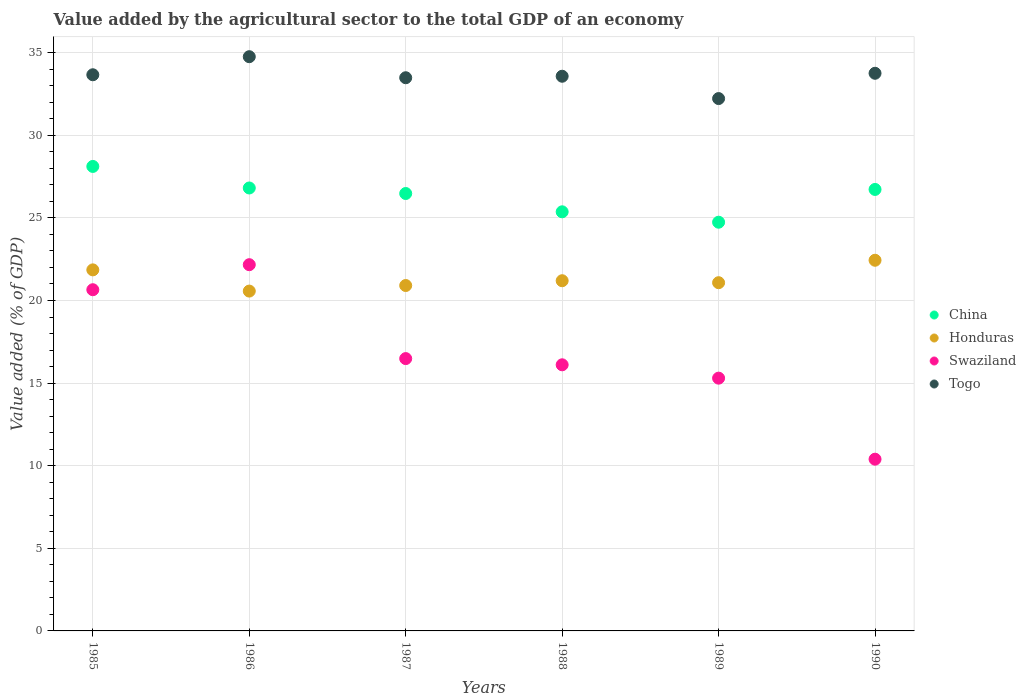How many different coloured dotlines are there?
Ensure brevity in your answer.  4. Is the number of dotlines equal to the number of legend labels?
Your answer should be very brief. Yes. What is the value added by the agricultural sector to the total GDP in Togo in 1989?
Give a very brief answer. 32.22. Across all years, what is the maximum value added by the agricultural sector to the total GDP in Togo?
Make the answer very short. 34.76. Across all years, what is the minimum value added by the agricultural sector to the total GDP in Togo?
Keep it short and to the point. 32.22. In which year was the value added by the agricultural sector to the total GDP in Honduras maximum?
Your response must be concise. 1990. In which year was the value added by the agricultural sector to the total GDP in Swaziland minimum?
Your answer should be compact. 1990. What is the total value added by the agricultural sector to the total GDP in China in the graph?
Provide a short and direct response. 158.23. What is the difference between the value added by the agricultural sector to the total GDP in China in 1987 and that in 1990?
Ensure brevity in your answer.  -0.25. What is the difference between the value added by the agricultural sector to the total GDP in China in 1989 and the value added by the agricultural sector to the total GDP in Togo in 1987?
Provide a short and direct response. -8.75. What is the average value added by the agricultural sector to the total GDP in Honduras per year?
Provide a short and direct response. 21.34. In the year 1986, what is the difference between the value added by the agricultural sector to the total GDP in Swaziland and value added by the agricultural sector to the total GDP in Honduras?
Your answer should be compact. 1.6. What is the ratio of the value added by the agricultural sector to the total GDP in Swaziland in 1985 to that in 1986?
Your answer should be very brief. 0.93. Is the value added by the agricultural sector to the total GDP in Honduras in 1989 less than that in 1990?
Provide a succinct answer. Yes. Is the difference between the value added by the agricultural sector to the total GDP in Swaziland in 1985 and 1986 greater than the difference between the value added by the agricultural sector to the total GDP in Honduras in 1985 and 1986?
Your answer should be very brief. No. What is the difference between the highest and the second highest value added by the agricultural sector to the total GDP in Swaziland?
Your response must be concise. 1.51. What is the difference between the highest and the lowest value added by the agricultural sector to the total GDP in Honduras?
Ensure brevity in your answer.  1.87. Is the sum of the value added by the agricultural sector to the total GDP in China in 1985 and 1986 greater than the maximum value added by the agricultural sector to the total GDP in Honduras across all years?
Offer a terse response. Yes. Does the value added by the agricultural sector to the total GDP in Togo monotonically increase over the years?
Give a very brief answer. No. Is the value added by the agricultural sector to the total GDP in Swaziland strictly greater than the value added by the agricultural sector to the total GDP in Honduras over the years?
Your answer should be very brief. No. Is the value added by the agricultural sector to the total GDP in Swaziland strictly less than the value added by the agricultural sector to the total GDP in Togo over the years?
Ensure brevity in your answer.  Yes. How many years are there in the graph?
Your response must be concise. 6. What is the title of the graph?
Offer a very short reply. Value added by the agricultural sector to the total GDP of an economy. Does "Libya" appear as one of the legend labels in the graph?
Offer a terse response. No. What is the label or title of the Y-axis?
Offer a very short reply. Value added (% of GDP). What is the Value added (% of GDP) in China in 1985?
Keep it short and to the point. 28.12. What is the Value added (% of GDP) in Honduras in 1985?
Offer a terse response. 21.85. What is the Value added (% of GDP) in Swaziland in 1985?
Give a very brief answer. 20.65. What is the Value added (% of GDP) in Togo in 1985?
Provide a succinct answer. 33.66. What is the Value added (% of GDP) in China in 1986?
Your answer should be very brief. 26.81. What is the Value added (% of GDP) of Honduras in 1986?
Ensure brevity in your answer.  20.57. What is the Value added (% of GDP) of Swaziland in 1986?
Give a very brief answer. 22.17. What is the Value added (% of GDP) of Togo in 1986?
Provide a short and direct response. 34.76. What is the Value added (% of GDP) of China in 1987?
Give a very brief answer. 26.48. What is the Value added (% of GDP) in Honduras in 1987?
Provide a short and direct response. 20.91. What is the Value added (% of GDP) of Swaziland in 1987?
Your answer should be compact. 16.48. What is the Value added (% of GDP) in Togo in 1987?
Offer a terse response. 33.48. What is the Value added (% of GDP) in China in 1988?
Ensure brevity in your answer.  25.37. What is the Value added (% of GDP) in Honduras in 1988?
Offer a very short reply. 21.2. What is the Value added (% of GDP) in Swaziland in 1988?
Make the answer very short. 16.11. What is the Value added (% of GDP) of Togo in 1988?
Offer a terse response. 33.57. What is the Value added (% of GDP) of China in 1989?
Give a very brief answer. 24.74. What is the Value added (% of GDP) of Honduras in 1989?
Your answer should be very brief. 21.08. What is the Value added (% of GDP) in Swaziland in 1989?
Give a very brief answer. 15.3. What is the Value added (% of GDP) in Togo in 1989?
Offer a terse response. 32.22. What is the Value added (% of GDP) of China in 1990?
Give a very brief answer. 26.72. What is the Value added (% of GDP) in Honduras in 1990?
Give a very brief answer. 22.44. What is the Value added (% of GDP) in Swaziland in 1990?
Provide a succinct answer. 10.4. What is the Value added (% of GDP) of Togo in 1990?
Provide a succinct answer. 33.75. Across all years, what is the maximum Value added (% of GDP) of China?
Your answer should be compact. 28.12. Across all years, what is the maximum Value added (% of GDP) in Honduras?
Keep it short and to the point. 22.44. Across all years, what is the maximum Value added (% of GDP) of Swaziland?
Offer a terse response. 22.17. Across all years, what is the maximum Value added (% of GDP) in Togo?
Provide a succinct answer. 34.76. Across all years, what is the minimum Value added (% of GDP) of China?
Provide a succinct answer. 24.74. Across all years, what is the minimum Value added (% of GDP) in Honduras?
Your answer should be very brief. 20.57. Across all years, what is the minimum Value added (% of GDP) of Swaziland?
Give a very brief answer. 10.4. Across all years, what is the minimum Value added (% of GDP) of Togo?
Ensure brevity in your answer.  32.22. What is the total Value added (% of GDP) in China in the graph?
Keep it short and to the point. 158.23. What is the total Value added (% of GDP) of Honduras in the graph?
Offer a terse response. 128.04. What is the total Value added (% of GDP) in Swaziland in the graph?
Ensure brevity in your answer.  101.11. What is the total Value added (% of GDP) in Togo in the graph?
Your answer should be very brief. 201.46. What is the difference between the Value added (% of GDP) of China in 1985 and that in 1986?
Ensure brevity in your answer.  1.3. What is the difference between the Value added (% of GDP) in Honduras in 1985 and that in 1986?
Provide a short and direct response. 1.28. What is the difference between the Value added (% of GDP) in Swaziland in 1985 and that in 1986?
Offer a terse response. -1.51. What is the difference between the Value added (% of GDP) of Togo in 1985 and that in 1986?
Your response must be concise. -1.09. What is the difference between the Value added (% of GDP) of China in 1985 and that in 1987?
Keep it short and to the point. 1.64. What is the difference between the Value added (% of GDP) in Honduras in 1985 and that in 1987?
Your response must be concise. 0.95. What is the difference between the Value added (% of GDP) of Swaziland in 1985 and that in 1987?
Your answer should be compact. 4.17. What is the difference between the Value added (% of GDP) in Togo in 1985 and that in 1987?
Your answer should be very brief. 0.18. What is the difference between the Value added (% of GDP) of China in 1985 and that in 1988?
Your answer should be very brief. 2.75. What is the difference between the Value added (% of GDP) of Honduras in 1985 and that in 1988?
Make the answer very short. 0.66. What is the difference between the Value added (% of GDP) in Swaziland in 1985 and that in 1988?
Keep it short and to the point. 4.54. What is the difference between the Value added (% of GDP) of Togo in 1985 and that in 1988?
Ensure brevity in your answer.  0.09. What is the difference between the Value added (% of GDP) of China in 1985 and that in 1989?
Offer a terse response. 3.38. What is the difference between the Value added (% of GDP) in Honduras in 1985 and that in 1989?
Provide a succinct answer. 0.78. What is the difference between the Value added (% of GDP) of Swaziland in 1985 and that in 1989?
Provide a short and direct response. 5.35. What is the difference between the Value added (% of GDP) in Togo in 1985 and that in 1989?
Offer a terse response. 1.44. What is the difference between the Value added (% of GDP) of China in 1985 and that in 1990?
Your answer should be compact. 1.39. What is the difference between the Value added (% of GDP) in Honduras in 1985 and that in 1990?
Ensure brevity in your answer.  -0.58. What is the difference between the Value added (% of GDP) of Swaziland in 1985 and that in 1990?
Ensure brevity in your answer.  10.26. What is the difference between the Value added (% of GDP) in Togo in 1985 and that in 1990?
Provide a short and direct response. -0.09. What is the difference between the Value added (% of GDP) in China in 1986 and that in 1987?
Ensure brevity in your answer.  0.33. What is the difference between the Value added (% of GDP) in Honduras in 1986 and that in 1987?
Your response must be concise. -0.34. What is the difference between the Value added (% of GDP) in Swaziland in 1986 and that in 1987?
Provide a short and direct response. 5.68. What is the difference between the Value added (% of GDP) of Togo in 1986 and that in 1987?
Make the answer very short. 1.27. What is the difference between the Value added (% of GDP) in China in 1986 and that in 1988?
Offer a very short reply. 1.44. What is the difference between the Value added (% of GDP) in Honduras in 1986 and that in 1988?
Your answer should be very brief. -0.63. What is the difference between the Value added (% of GDP) in Swaziland in 1986 and that in 1988?
Provide a succinct answer. 6.06. What is the difference between the Value added (% of GDP) of Togo in 1986 and that in 1988?
Ensure brevity in your answer.  1.18. What is the difference between the Value added (% of GDP) of China in 1986 and that in 1989?
Your answer should be very brief. 2.07. What is the difference between the Value added (% of GDP) in Honduras in 1986 and that in 1989?
Your response must be concise. -0.51. What is the difference between the Value added (% of GDP) in Swaziland in 1986 and that in 1989?
Your answer should be compact. 6.87. What is the difference between the Value added (% of GDP) of Togo in 1986 and that in 1989?
Provide a succinct answer. 2.53. What is the difference between the Value added (% of GDP) in China in 1986 and that in 1990?
Give a very brief answer. 0.09. What is the difference between the Value added (% of GDP) of Honduras in 1986 and that in 1990?
Make the answer very short. -1.87. What is the difference between the Value added (% of GDP) of Swaziland in 1986 and that in 1990?
Your answer should be very brief. 11.77. What is the difference between the Value added (% of GDP) in Togo in 1986 and that in 1990?
Ensure brevity in your answer.  1. What is the difference between the Value added (% of GDP) of China in 1987 and that in 1988?
Provide a short and direct response. 1.11. What is the difference between the Value added (% of GDP) of Honduras in 1987 and that in 1988?
Give a very brief answer. -0.29. What is the difference between the Value added (% of GDP) of Swaziland in 1987 and that in 1988?
Your answer should be compact. 0.38. What is the difference between the Value added (% of GDP) in Togo in 1987 and that in 1988?
Provide a short and direct response. -0.09. What is the difference between the Value added (% of GDP) in China in 1987 and that in 1989?
Keep it short and to the point. 1.74. What is the difference between the Value added (% of GDP) of Honduras in 1987 and that in 1989?
Make the answer very short. -0.17. What is the difference between the Value added (% of GDP) of Swaziland in 1987 and that in 1989?
Your response must be concise. 1.18. What is the difference between the Value added (% of GDP) in Togo in 1987 and that in 1989?
Keep it short and to the point. 1.26. What is the difference between the Value added (% of GDP) of China in 1987 and that in 1990?
Give a very brief answer. -0.25. What is the difference between the Value added (% of GDP) in Honduras in 1987 and that in 1990?
Ensure brevity in your answer.  -1.53. What is the difference between the Value added (% of GDP) of Swaziland in 1987 and that in 1990?
Offer a terse response. 6.09. What is the difference between the Value added (% of GDP) of Togo in 1987 and that in 1990?
Your answer should be very brief. -0.27. What is the difference between the Value added (% of GDP) of China in 1988 and that in 1989?
Your answer should be compact. 0.63. What is the difference between the Value added (% of GDP) of Honduras in 1988 and that in 1989?
Keep it short and to the point. 0.12. What is the difference between the Value added (% of GDP) of Swaziland in 1988 and that in 1989?
Your response must be concise. 0.81. What is the difference between the Value added (% of GDP) of Togo in 1988 and that in 1989?
Give a very brief answer. 1.35. What is the difference between the Value added (% of GDP) in China in 1988 and that in 1990?
Provide a succinct answer. -1.35. What is the difference between the Value added (% of GDP) in Honduras in 1988 and that in 1990?
Provide a succinct answer. -1.24. What is the difference between the Value added (% of GDP) in Swaziland in 1988 and that in 1990?
Your response must be concise. 5.71. What is the difference between the Value added (% of GDP) in Togo in 1988 and that in 1990?
Offer a terse response. -0.18. What is the difference between the Value added (% of GDP) of China in 1989 and that in 1990?
Offer a very short reply. -1.98. What is the difference between the Value added (% of GDP) in Honduras in 1989 and that in 1990?
Ensure brevity in your answer.  -1.36. What is the difference between the Value added (% of GDP) of Swaziland in 1989 and that in 1990?
Provide a succinct answer. 4.91. What is the difference between the Value added (% of GDP) of Togo in 1989 and that in 1990?
Provide a short and direct response. -1.53. What is the difference between the Value added (% of GDP) in China in 1985 and the Value added (% of GDP) in Honduras in 1986?
Provide a short and direct response. 7.55. What is the difference between the Value added (% of GDP) of China in 1985 and the Value added (% of GDP) of Swaziland in 1986?
Make the answer very short. 5.95. What is the difference between the Value added (% of GDP) in China in 1985 and the Value added (% of GDP) in Togo in 1986?
Make the answer very short. -6.64. What is the difference between the Value added (% of GDP) in Honduras in 1985 and the Value added (% of GDP) in Swaziland in 1986?
Keep it short and to the point. -0.31. What is the difference between the Value added (% of GDP) of Honduras in 1985 and the Value added (% of GDP) of Togo in 1986?
Offer a terse response. -12.9. What is the difference between the Value added (% of GDP) of Swaziland in 1985 and the Value added (% of GDP) of Togo in 1986?
Your response must be concise. -14.1. What is the difference between the Value added (% of GDP) in China in 1985 and the Value added (% of GDP) in Honduras in 1987?
Ensure brevity in your answer.  7.21. What is the difference between the Value added (% of GDP) of China in 1985 and the Value added (% of GDP) of Swaziland in 1987?
Your answer should be very brief. 11.63. What is the difference between the Value added (% of GDP) of China in 1985 and the Value added (% of GDP) of Togo in 1987?
Make the answer very short. -5.37. What is the difference between the Value added (% of GDP) of Honduras in 1985 and the Value added (% of GDP) of Swaziland in 1987?
Offer a terse response. 5.37. What is the difference between the Value added (% of GDP) of Honduras in 1985 and the Value added (% of GDP) of Togo in 1987?
Make the answer very short. -11.63. What is the difference between the Value added (% of GDP) of Swaziland in 1985 and the Value added (% of GDP) of Togo in 1987?
Ensure brevity in your answer.  -12.83. What is the difference between the Value added (% of GDP) in China in 1985 and the Value added (% of GDP) in Honduras in 1988?
Make the answer very short. 6.92. What is the difference between the Value added (% of GDP) of China in 1985 and the Value added (% of GDP) of Swaziland in 1988?
Make the answer very short. 12.01. What is the difference between the Value added (% of GDP) of China in 1985 and the Value added (% of GDP) of Togo in 1988?
Ensure brevity in your answer.  -5.46. What is the difference between the Value added (% of GDP) of Honduras in 1985 and the Value added (% of GDP) of Swaziland in 1988?
Offer a terse response. 5.75. What is the difference between the Value added (% of GDP) in Honduras in 1985 and the Value added (% of GDP) in Togo in 1988?
Keep it short and to the point. -11.72. What is the difference between the Value added (% of GDP) of Swaziland in 1985 and the Value added (% of GDP) of Togo in 1988?
Provide a succinct answer. -12.92. What is the difference between the Value added (% of GDP) in China in 1985 and the Value added (% of GDP) in Honduras in 1989?
Offer a very short reply. 7.04. What is the difference between the Value added (% of GDP) in China in 1985 and the Value added (% of GDP) in Swaziland in 1989?
Provide a succinct answer. 12.82. What is the difference between the Value added (% of GDP) of China in 1985 and the Value added (% of GDP) of Togo in 1989?
Offer a very short reply. -4.11. What is the difference between the Value added (% of GDP) of Honduras in 1985 and the Value added (% of GDP) of Swaziland in 1989?
Your answer should be compact. 6.55. What is the difference between the Value added (% of GDP) of Honduras in 1985 and the Value added (% of GDP) of Togo in 1989?
Offer a very short reply. -10.37. What is the difference between the Value added (% of GDP) of Swaziland in 1985 and the Value added (% of GDP) of Togo in 1989?
Provide a succinct answer. -11.57. What is the difference between the Value added (% of GDP) in China in 1985 and the Value added (% of GDP) in Honduras in 1990?
Provide a short and direct response. 5.68. What is the difference between the Value added (% of GDP) in China in 1985 and the Value added (% of GDP) in Swaziland in 1990?
Offer a very short reply. 17.72. What is the difference between the Value added (% of GDP) in China in 1985 and the Value added (% of GDP) in Togo in 1990?
Keep it short and to the point. -5.64. What is the difference between the Value added (% of GDP) in Honduras in 1985 and the Value added (% of GDP) in Swaziland in 1990?
Ensure brevity in your answer.  11.46. What is the difference between the Value added (% of GDP) of Honduras in 1985 and the Value added (% of GDP) of Togo in 1990?
Offer a very short reply. -11.9. What is the difference between the Value added (% of GDP) in Swaziland in 1985 and the Value added (% of GDP) in Togo in 1990?
Keep it short and to the point. -13.1. What is the difference between the Value added (% of GDP) of China in 1986 and the Value added (% of GDP) of Honduras in 1987?
Offer a terse response. 5.9. What is the difference between the Value added (% of GDP) of China in 1986 and the Value added (% of GDP) of Swaziland in 1987?
Keep it short and to the point. 10.33. What is the difference between the Value added (% of GDP) in China in 1986 and the Value added (% of GDP) in Togo in 1987?
Offer a very short reply. -6.67. What is the difference between the Value added (% of GDP) in Honduras in 1986 and the Value added (% of GDP) in Swaziland in 1987?
Your answer should be compact. 4.09. What is the difference between the Value added (% of GDP) in Honduras in 1986 and the Value added (% of GDP) in Togo in 1987?
Provide a succinct answer. -12.91. What is the difference between the Value added (% of GDP) in Swaziland in 1986 and the Value added (% of GDP) in Togo in 1987?
Provide a short and direct response. -11.32. What is the difference between the Value added (% of GDP) in China in 1986 and the Value added (% of GDP) in Honduras in 1988?
Your answer should be very brief. 5.61. What is the difference between the Value added (% of GDP) in China in 1986 and the Value added (% of GDP) in Swaziland in 1988?
Provide a succinct answer. 10.7. What is the difference between the Value added (% of GDP) in China in 1986 and the Value added (% of GDP) in Togo in 1988?
Provide a short and direct response. -6.76. What is the difference between the Value added (% of GDP) of Honduras in 1986 and the Value added (% of GDP) of Swaziland in 1988?
Ensure brevity in your answer.  4.46. What is the difference between the Value added (% of GDP) in Honduras in 1986 and the Value added (% of GDP) in Togo in 1988?
Your answer should be compact. -13. What is the difference between the Value added (% of GDP) of Swaziland in 1986 and the Value added (% of GDP) of Togo in 1988?
Your response must be concise. -11.41. What is the difference between the Value added (% of GDP) in China in 1986 and the Value added (% of GDP) in Honduras in 1989?
Your answer should be compact. 5.73. What is the difference between the Value added (% of GDP) of China in 1986 and the Value added (% of GDP) of Swaziland in 1989?
Your answer should be very brief. 11.51. What is the difference between the Value added (% of GDP) in China in 1986 and the Value added (% of GDP) in Togo in 1989?
Your answer should be compact. -5.41. What is the difference between the Value added (% of GDP) in Honduras in 1986 and the Value added (% of GDP) in Swaziland in 1989?
Make the answer very short. 5.27. What is the difference between the Value added (% of GDP) of Honduras in 1986 and the Value added (% of GDP) of Togo in 1989?
Give a very brief answer. -11.65. What is the difference between the Value added (% of GDP) in Swaziland in 1986 and the Value added (% of GDP) in Togo in 1989?
Provide a succinct answer. -10.06. What is the difference between the Value added (% of GDP) of China in 1986 and the Value added (% of GDP) of Honduras in 1990?
Offer a terse response. 4.37. What is the difference between the Value added (% of GDP) of China in 1986 and the Value added (% of GDP) of Swaziland in 1990?
Your response must be concise. 16.42. What is the difference between the Value added (% of GDP) of China in 1986 and the Value added (% of GDP) of Togo in 1990?
Make the answer very short. -6.94. What is the difference between the Value added (% of GDP) in Honduras in 1986 and the Value added (% of GDP) in Swaziland in 1990?
Give a very brief answer. 10.18. What is the difference between the Value added (% of GDP) of Honduras in 1986 and the Value added (% of GDP) of Togo in 1990?
Ensure brevity in your answer.  -13.18. What is the difference between the Value added (% of GDP) in Swaziland in 1986 and the Value added (% of GDP) in Togo in 1990?
Your answer should be very brief. -11.59. What is the difference between the Value added (% of GDP) in China in 1987 and the Value added (% of GDP) in Honduras in 1988?
Offer a terse response. 5.28. What is the difference between the Value added (% of GDP) in China in 1987 and the Value added (% of GDP) in Swaziland in 1988?
Provide a short and direct response. 10.37. What is the difference between the Value added (% of GDP) of China in 1987 and the Value added (% of GDP) of Togo in 1988?
Make the answer very short. -7.1. What is the difference between the Value added (% of GDP) in Honduras in 1987 and the Value added (% of GDP) in Swaziland in 1988?
Your answer should be very brief. 4.8. What is the difference between the Value added (% of GDP) in Honduras in 1987 and the Value added (% of GDP) in Togo in 1988?
Your response must be concise. -12.67. What is the difference between the Value added (% of GDP) of Swaziland in 1987 and the Value added (% of GDP) of Togo in 1988?
Your response must be concise. -17.09. What is the difference between the Value added (% of GDP) of China in 1987 and the Value added (% of GDP) of Honduras in 1989?
Ensure brevity in your answer.  5.4. What is the difference between the Value added (% of GDP) in China in 1987 and the Value added (% of GDP) in Swaziland in 1989?
Keep it short and to the point. 11.18. What is the difference between the Value added (% of GDP) of China in 1987 and the Value added (% of GDP) of Togo in 1989?
Offer a terse response. -5.75. What is the difference between the Value added (% of GDP) in Honduras in 1987 and the Value added (% of GDP) in Swaziland in 1989?
Provide a succinct answer. 5.61. What is the difference between the Value added (% of GDP) of Honduras in 1987 and the Value added (% of GDP) of Togo in 1989?
Ensure brevity in your answer.  -11.32. What is the difference between the Value added (% of GDP) of Swaziland in 1987 and the Value added (% of GDP) of Togo in 1989?
Make the answer very short. -15.74. What is the difference between the Value added (% of GDP) of China in 1987 and the Value added (% of GDP) of Honduras in 1990?
Your answer should be compact. 4.04. What is the difference between the Value added (% of GDP) in China in 1987 and the Value added (% of GDP) in Swaziland in 1990?
Provide a succinct answer. 16.08. What is the difference between the Value added (% of GDP) in China in 1987 and the Value added (% of GDP) in Togo in 1990?
Your answer should be compact. -7.28. What is the difference between the Value added (% of GDP) of Honduras in 1987 and the Value added (% of GDP) of Swaziland in 1990?
Offer a very short reply. 10.51. What is the difference between the Value added (% of GDP) of Honduras in 1987 and the Value added (% of GDP) of Togo in 1990?
Offer a terse response. -12.85. What is the difference between the Value added (% of GDP) in Swaziland in 1987 and the Value added (% of GDP) in Togo in 1990?
Make the answer very short. -17.27. What is the difference between the Value added (% of GDP) of China in 1988 and the Value added (% of GDP) of Honduras in 1989?
Make the answer very short. 4.29. What is the difference between the Value added (% of GDP) in China in 1988 and the Value added (% of GDP) in Swaziland in 1989?
Your answer should be very brief. 10.07. What is the difference between the Value added (% of GDP) in China in 1988 and the Value added (% of GDP) in Togo in 1989?
Offer a terse response. -6.85. What is the difference between the Value added (% of GDP) in Honduras in 1988 and the Value added (% of GDP) in Swaziland in 1989?
Your response must be concise. 5.9. What is the difference between the Value added (% of GDP) in Honduras in 1988 and the Value added (% of GDP) in Togo in 1989?
Your answer should be very brief. -11.03. What is the difference between the Value added (% of GDP) of Swaziland in 1988 and the Value added (% of GDP) of Togo in 1989?
Ensure brevity in your answer.  -16.12. What is the difference between the Value added (% of GDP) of China in 1988 and the Value added (% of GDP) of Honduras in 1990?
Give a very brief answer. 2.93. What is the difference between the Value added (% of GDP) of China in 1988 and the Value added (% of GDP) of Swaziland in 1990?
Make the answer very short. 14.97. What is the difference between the Value added (% of GDP) in China in 1988 and the Value added (% of GDP) in Togo in 1990?
Offer a very short reply. -8.39. What is the difference between the Value added (% of GDP) of Honduras in 1988 and the Value added (% of GDP) of Swaziland in 1990?
Your answer should be very brief. 10.8. What is the difference between the Value added (% of GDP) in Honduras in 1988 and the Value added (% of GDP) in Togo in 1990?
Your response must be concise. -12.56. What is the difference between the Value added (% of GDP) in Swaziland in 1988 and the Value added (% of GDP) in Togo in 1990?
Offer a terse response. -17.65. What is the difference between the Value added (% of GDP) in China in 1989 and the Value added (% of GDP) in Honduras in 1990?
Offer a terse response. 2.3. What is the difference between the Value added (% of GDP) in China in 1989 and the Value added (% of GDP) in Swaziland in 1990?
Keep it short and to the point. 14.34. What is the difference between the Value added (% of GDP) in China in 1989 and the Value added (% of GDP) in Togo in 1990?
Provide a succinct answer. -9.01. What is the difference between the Value added (% of GDP) in Honduras in 1989 and the Value added (% of GDP) in Swaziland in 1990?
Give a very brief answer. 10.68. What is the difference between the Value added (% of GDP) of Honduras in 1989 and the Value added (% of GDP) of Togo in 1990?
Make the answer very short. -12.68. What is the difference between the Value added (% of GDP) of Swaziland in 1989 and the Value added (% of GDP) of Togo in 1990?
Offer a terse response. -18.45. What is the average Value added (% of GDP) of China per year?
Ensure brevity in your answer.  26.37. What is the average Value added (% of GDP) of Honduras per year?
Offer a terse response. 21.34. What is the average Value added (% of GDP) of Swaziland per year?
Offer a terse response. 16.85. What is the average Value added (% of GDP) in Togo per year?
Provide a succinct answer. 33.58. In the year 1985, what is the difference between the Value added (% of GDP) of China and Value added (% of GDP) of Honduras?
Offer a terse response. 6.26. In the year 1985, what is the difference between the Value added (% of GDP) in China and Value added (% of GDP) in Swaziland?
Offer a very short reply. 7.46. In the year 1985, what is the difference between the Value added (% of GDP) of China and Value added (% of GDP) of Togo?
Offer a terse response. -5.55. In the year 1985, what is the difference between the Value added (% of GDP) in Honduras and Value added (% of GDP) in Swaziland?
Your answer should be very brief. 1.2. In the year 1985, what is the difference between the Value added (% of GDP) in Honduras and Value added (% of GDP) in Togo?
Offer a very short reply. -11.81. In the year 1985, what is the difference between the Value added (% of GDP) in Swaziland and Value added (% of GDP) in Togo?
Make the answer very short. -13.01. In the year 1986, what is the difference between the Value added (% of GDP) of China and Value added (% of GDP) of Honduras?
Your answer should be very brief. 6.24. In the year 1986, what is the difference between the Value added (% of GDP) in China and Value added (% of GDP) in Swaziland?
Keep it short and to the point. 4.64. In the year 1986, what is the difference between the Value added (% of GDP) of China and Value added (% of GDP) of Togo?
Provide a short and direct response. -7.95. In the year 1986, what is the difference between the Value added (% of GDP) of Honduras and Value added (% of GDP) of Swaziland?
Your answer should be compact. -1.6. In the year 1986, what is the difference between the Value added (% of GDP) in Honduras and Value added (% of GDP) in Togo?
Keep it short and to the point. -14.19. In the year 1986, what is the difference between the Value added (% of GDP) of Swaziland and Value added (% of GDP) of Togo?
Give a very brief answer. -12.59. In the year 1987, what is the difference between the Value added (% of GDP) in China and Value added (% of GDP) in Honduras?
Offer a terse response. 5.57. In the year 1987, what is the difference between the Value added (% of GDP) of China and Value added (% of GDP) of Swaziland?
Ensure brevity in your answer.  9.99. In the year 1987, what is the difference between the Value added (% of GDP) in China and Value added (% of GDP) in Togo?
Offer a very short reply. -7.01. In the year 1987, what is the difference between the Value added (% of GDP) in Honduras and Value added (% of GDP) in Swaziland?
Provide a succinct answer. 4.42. In the year 1987, what is the difference between the Value added (% of GDP) of Honduras and Value added (% of GDP) of Togo?
Provide a succinct answer. -12.58. In the year 1987, what is the difference between the Value added (% of GDP) of Swaziland and Value added (% of GDP) of Togo?
Make the answer very short. -17. In the year 1988, what is the difference between the Value added (% of GDP) of China and Value added (% of GDP) of Honduras?
Offer a very short reply. 4.17. In the year 1988, what is the difference between the Value added (% of GDP) of China and Value added (% of GDP) of Swaziland?
Your answer should be compact. 9.26. In the year 1988, what is the difference between the Value added (% of GDP) of China and Value added (% of GDP) of Togo?
Offer a very short reply. -8.21. In the year 1988, what is the difference between the Value added (% of GDP) of Honduras and Value added (% of GDP) of Swaziland?
Offer a terse response. 5.09. In the year 1988, what is the difference between the Value added (% of GDP) in Honduras and Value added (% of GDP) in Togo?
Make the answer very short. -12.38. In the year 1988, what is the difference between the Value added (% of GDP) in Swaziland and Value added (% of GDP) in Togo?
Your answer should be very brief. -17.47. In the year 1989, what is the difference between the Value added (% of GDP) in China and Value added (% of GDP) in Honduras?
Provide a succinct answer. 3.66. In the year 1989, what is the difference between the Value added (% of GDP) in China and Value added (% of GDP) in Swaziland?
Ensure brevity in your answer.  9.44. In the year 1989, what is the difference between the Value added (% of GDP) in China and Value added (% of GDP) in Togo?
Provide a succinct answer. -7.48. In the year 1989, what is the difference between the Value added (% of GDP) in Honduras and Value added (% of GDP) in Swaziland?
Make the answer very short. 5.78. In the year 1989, what is the difference between the Value added (% of GDP) of Honduras and Value added (% of GDP) of Togo?
Make the answer very short. -11.15. In the year 1989, what is the difference between the Value added (% of GDP) of Swaziland and Value added (% of GDP) of Togo?
Keep it short and to the point. -16.92. In the year 1990, what is the difference between the Value added (% of GDP) in China and Value added (% of GDP) in Honduras?
Ensure brevity in your answer.  4.29. In the year 1990, what is the difference between the Value added (% of GDP) in China and Value added (% of GDP) in Swaziland?
Offer a terse response. 16.33. In the year 1990, what is the difference between the Value added (% of GDP) of China and Value added (% of GDP) of Togo?
Ensure brevity in your answer.  -7.03. In the year 1990, what is the difference between the Value added (% of GDP) in Honduras and Value added (% of GDP) in Swaziland?
Provide a short and direct response. 12.04. In the year 1990, what is the difference between the Value added (% of GDP) in Honduras and Value added (% of GDP) in Togo?
Provide a short and direct response. -11.32. In the year 1990, what is the difference between the Value added (% of GDP) in Swaziland and Value added (% of GDP) in Togo?
Your answer should be compact. -23.36. What is the ratio of the Value added (% of GDP) of China in 1985 to that in 1986?
Your answer should be compact. 1.05. What is the ratio of the Value added (% of GDP) of Honduras in 1985 to that in 1986?
Give a very brief answer. 1.06. What is the ratio of the Value added (% of GDP) of Swaziland in 1985 to that in 1986?
Keep it short and to the point. 0.93. What is the ratio of the Value added (% of GDP) of Togo in 1985 to that in 1986?
Your response must be concise. 0.97. What is the ratio of the Value added (% of GDP) of China in 1985 to that in 1987?
Your response must be concise. 1.06. What is the ratio of the Value added (% of GDP) of Honduras in 1985 to that in 1987?
Your answer should be compact. 1.05. What is the ratio of the Value added (% of GDP) in Swaziland in 1985 to that in 1987?
Your answer should be compact. 1.25. What is the ratio of the Value added (% of GDP) in Togo in 1985 to that in 1987?
Your response must be concise. 1.01. What is the ratio of the Value added (% of GDP) of China in 1985 to that in 1988?
Your answer should be compact. 1.11. What is the ratio of the Value added (% of GDP) of Honduras in 1985 to that in 1988?
Provide a short and direct response. 1.03. What is the ratio of the Value added (% of GDP) in Swaziland in 1985 to that in 1988?
Give a very brief answer. 1.28. What is the ratio of the Value added (% of GDP) in Togo in 1985 to that in 1988?
Your response must be concise. 1. What is the ratio of the Value added (% of GDP) in China in 1985 to that in 1989?
Give a very brief answer. 1.14. What is the ratio of the Value added (% of GDP) in Honduras in 1985 to that in 1989?
Give a very brief answer. 1.04. What is the ratio of the Value added (% of GDP) of Swaziland in 1985 to that in 1989?
Make the answer very short. 1.35. What is the ratio of the Value added (% of GDP) of Togo in 1985 to that in 1989?
Offer a terse response. 1.04. What is the ratio of the Value added (% of GDP) in China in 1985 to that in 1990?
Your answer should be compact. 1.05. What is the ratio of the Value added (% of GDP) in Honduras in 1985 to that in 1990?
Your response must be concise. 0.97. What is the ratio of the Value added (% of GDP) in Swaziland in 1985 to that in 1990?
Your response must be concise. 1.99. What is the ratio of the Value added (% of GDP) in Togo in 1985 to that in 1990?
Ensure brevity in your answer.  1. What is the ratio of the Value added (% of GDP) in China in 1986 to that in 1987?
Offer a terse response. 1.01. What is the ratio of the Value added (% of GDP) in Honduras in 1986 to that in 1987?
Provide a succinct answer. 0.98. What is the ratio of the Value added (% of GDP) in Swaziland in 1986 to that in 1987?
Your response must be concise. 1.34. What is the ratio of the Value added (% of GDP) in Togo in 1986 to that in 1987?
Your answer should be compact. 1.04. What is the ratio of the Value added (% of GDP) of China in 1986 to that in 1988?
Give a very brief answer. 1.06. What is the ratio of the Value added (% of GDP) of Honduras in 1986 to that in 1988?
Give a very brief answer. 0.97. What is the ratio of the Value added (% of GDP) in Swaziland in 1986 to that in 1988?
Make the answer very short. 1.38. What is the ratio of the Value added (% of GDP) of Togo in 1986 to that in 1988?
Offer a terse response. 1.04. What is the ratio of the Value added (% of GDP) in China in 1986 to that in 1989?
Your answer should be very brief. 1.08. What is the ratio of the Value added (% of GDP) in Honduras in 1986 to that in 1989?
Ensure brevity in your answer.  0.98. What is the ratio of the Value added (% of GDP) of Swaziland in 1986 to that in 1989?
Offer a terse response. 1.45. What is the ratio of the Value added (% of GDP) of Togo in 1986 to that in 1989?
Your response must be concise. 1.08. What is the ratio of the Value added (% of GDP) in China in 1986 to that in 1990?
Your answer should be very brief. 1. What is the ratio of the Value added (% of GDP) of Honduras in 1986 to that in 1990?
Give a very brief answer. 0.92. What is the ratio of the Value added (% of GDP) of Swaziland in 1986 to that in 1990?
Your response must be concise. 2.13. What is the ratio of the Value added (% of GDP) in Togo in 1986 to that in 1990?
Keep it short and to the point. 1.03. What is the ratio of the Value added (% of GDP) in China in 1987 to that in 1988?
Your answer should be very brief. 1.04. What is the ratio of the Value added (% of GDP) in Honduras in 1987 to that in 1988?
Your answer should be very brief. 0.99. What is the ratio of the Value added (% of GDP) of Swaziland in 1987 to that in 1988?
Provide a short and direct response. 1.02. What is the ratio of the Value added (% of GDP) of Togo in 1987 to that in 1988?
Your answer should be very brief. 1. What is the ratio of the Value added (% of GDP) of China in 1987 to that in 1989?
Ensure brevity in your answer.  1.07. What is the ratio of the Value added (% of GDP) of Swaziland in 1987 to that in 1989?
Offer a terse response. 1.08. What is the ratio of the Value added (% of GDP) in Togo in 1987 to that in 1989?
Keep it short and to the point. 1.04. What is the ratio of the Value added (% of GDP) in China in 1987 to that in 1990?
Offer a terse response. 0.99. What is the ratio of the Value added (% of GDP) of Honduras in 1987 to that in 1990?
Provide a succinct answer. 0.93. What is the ratio of the Value added (% of GDP) of Swaziland in 1987 to that in 1990?
Offer a terse response. 1.59. What is the ratio of the Value added (% of GDP) in Togo in 1987 to that in 1990?
Provide a succinct answer. 0.99. What is the ratio of the Value added (% of GDP) of China in 1988 to that in 1989?
Offer a very short reply. 1.03. What is the ratio of the Value added (% of GDP) in Honduras in 1988 to that in 1989?
Ensure brevity in your answer.  1.01. What is the ratio of the Value added (% of GDP) in Swaziland in 1988 to that in 1989?
Give a very brief answer. 1.05. What is the ratio of the Value added (% of GDP) of Togo in 1988 to that in 1989?
Offer a very short reply. 1.04. What is the ratio of the Value added (% of GDP) of China in 1988 to that in 1990?
Make the answer very short. 0.95. What is the ratio of the Value added (% of GDP) of Honduras in 1988 to that in 1990?
Provide a short and direct response. 0.94. What is the ratio of the Value added (% of GDP) in Swaziland in 1988 to that in 1990?
Ensure brevity in your answer.  1.55. What is the ratio of the Value added (% of GDP) in Togo in 1988 to that in 1990?
Provide a short and direct response. 0.99. What is the ratio of the Value added (% of GDP) of China in 1989 to that in 1990?
Your response must be concise. 0.93. What is the ratio of the Value added (% of GDP) of Honduras in 1989 to that in 1990?
Your response must be concise. 0.94. What is the ratio of the Value added (% of GDP) in Swaziland in 1989 to that in 1990?
Your answer should be very brief. 1.47. What is the ratio of the Value added (% of GDP) in Togo in 1989 to that in 1990?
Your answer should be compact. 0.95. What is the difference between the highest and the second highest Value added (% of GDP) in China?
Provide a short and direct response. 1.3. What is the difference between the highest and the second highest Value added (% of GDP) of Honduras?
Keep it short and to the point. 0.58. What is the difference between the highest and the second highest Value added (% of GDP) in Swaziland?
Provide a succinct answer. 1.51. What is the difference between the highest and the lowest Value added (% of GDP) in China?
Offer a very short reply. 3.38. What is the difference between the highest and the lowest Value added (% of GDP) of Honduras?
Provide a short and direct response. 1.87. What is the difference between the highest and the lowest Value added (% of GDP) of Swaziland?
Ensure brevity in your answer.  11.77. What is the difference between the highest and the lowest Value added (% of GDP) of Togo?
Provide a short and direct response. 2.53. 